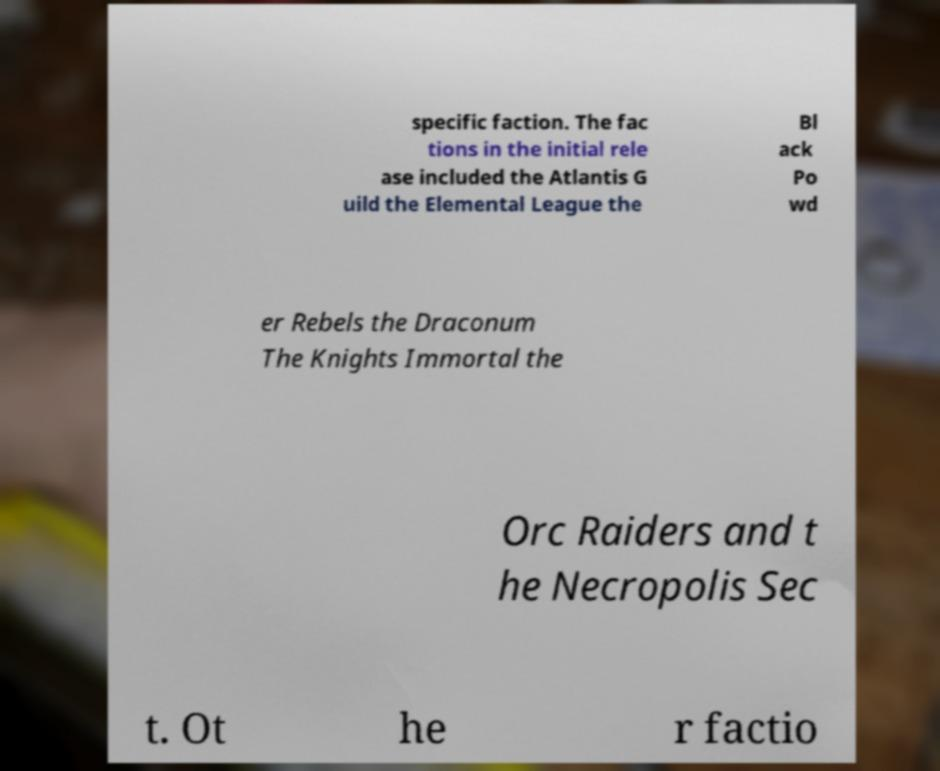There's text embedded in this image that I need extracted. Can you transcribe it verbatim? specific faction. The fac tions in the initial rele ase included the Atlantis G uild the Elemental League the Bl ack Po wd er Rebels the Draconum The Knights Immortal the Orc Raiders and t he Necropolis Sec t. Ot he r factio 